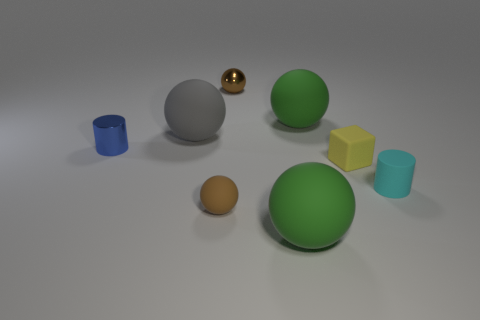There is a large sphere left of the large green rubber object that is in front of the small blue metallic cylinder; what is its color?
Your answer should be very brief. Gray. There is a large thing that is on the right side of the large gray ball and behind the tiny metal cylinder; what is it made of?
Offer a very short reply. Rubber. Are there any other yellow matte objects that have the same shape as the yellow object?
Keep it short and to the point. No. Do the brown shiny thing behind the yellow object and the gray matte thing have the same shape?
Give a very brief answer. Yes. What number of objects are right of the large gray rubber thing and in front of the large gray matte sphere?
Offer a terse response. 4. The large green object behind the small metallic cylinder has what shape?
Your answer should be compact. Sphere. How many cyan objects are made of the same material as the large gray thing?
Your response must be concise. 1. There is a small brown metal object; is its shape the same as the metal thing in front of the big gray ball?
Your response must be concise. No. There is a small yellow block behind the large green rubber sphere that is in front of the tiny cyan rubber cylinder; is there a green matte object that is to the right of it?
Your response must be concise. No. How big is the brown sphere that is behind the small cyan cylinder?
Your answer should be very brief. Small. 